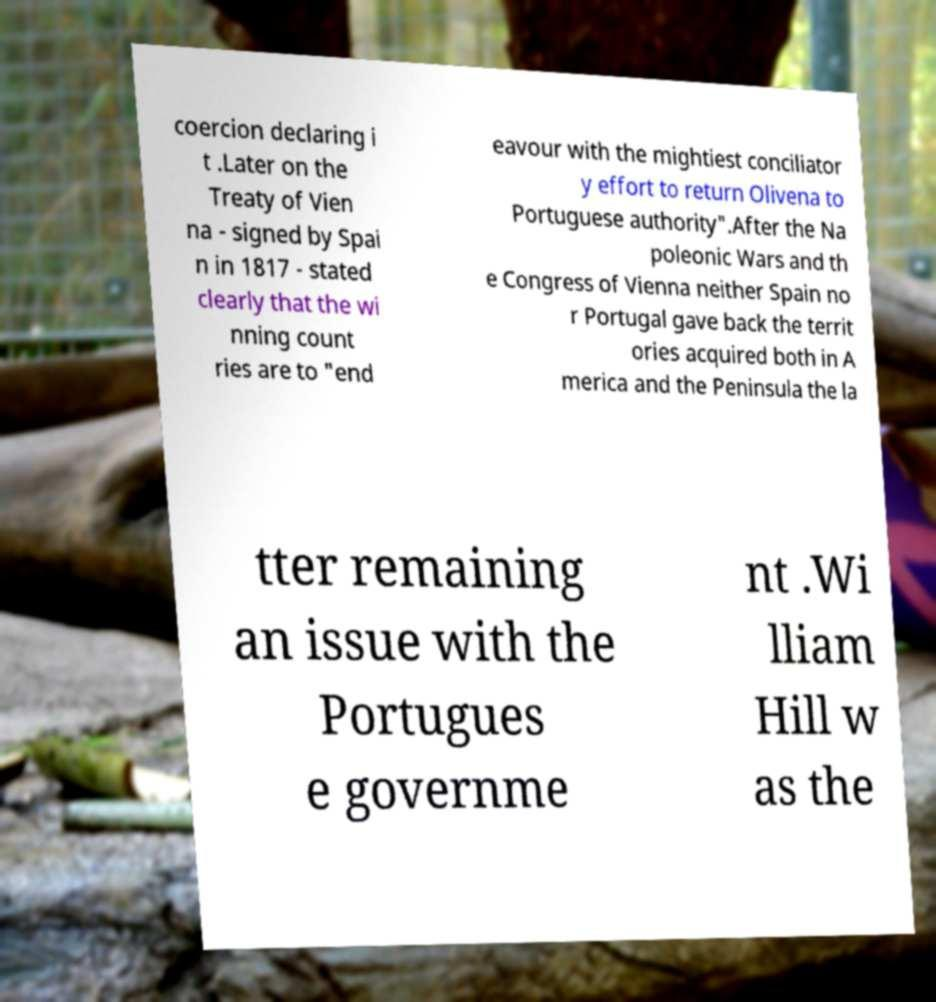Could you assist in decoding the text presented in this image and type it out clearly? coercion declaring i t .Later on the Treaty of Vien na - signed by Spai n in 1817 - stated clearly that the wi nning count ries are to "end eavour with the mightiest conciliator y effort to return Olivena to Portuguese authority".After the Na poleonic Wars and th e Congress of Vienna neither Spain no r Portugal gave back the territ ories acquired both in A merica and the Peninsula the la tter remaining an issue with the Portugues e governme nt .Wi lliam Hill w as the 